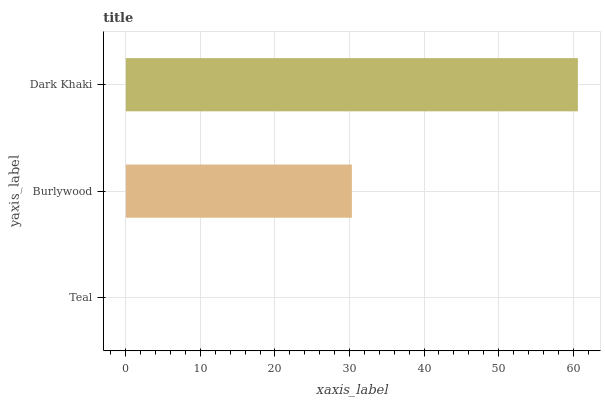Is Teal the minimum?
Answer yes or no. Yes. Is Dark Khaki the maximum?
Answer yes or no. Yes. Is Burlywood the minimum?
Answer yes or no. No. Is Burlywood the maximum?
Answer yes or no. No. Is Burlywood greater than Teal?
Answer yes or no. Yes. Is Teal less than Burlywood?
Answer yes or no. Yes. Is Teal greater than Burlywood?
Answer yes or no. No. Is Burlywood less than Teal?
Answer yes or no. No. Is Burlywood the high median?
Answer yes or no. Yes. Is Burlywood the low median?
Answer yes or no. Yes. Is Dark Khaki the high median?
Answer yes or no. No. Is Teal the low median?
Answer yes or no. No. 